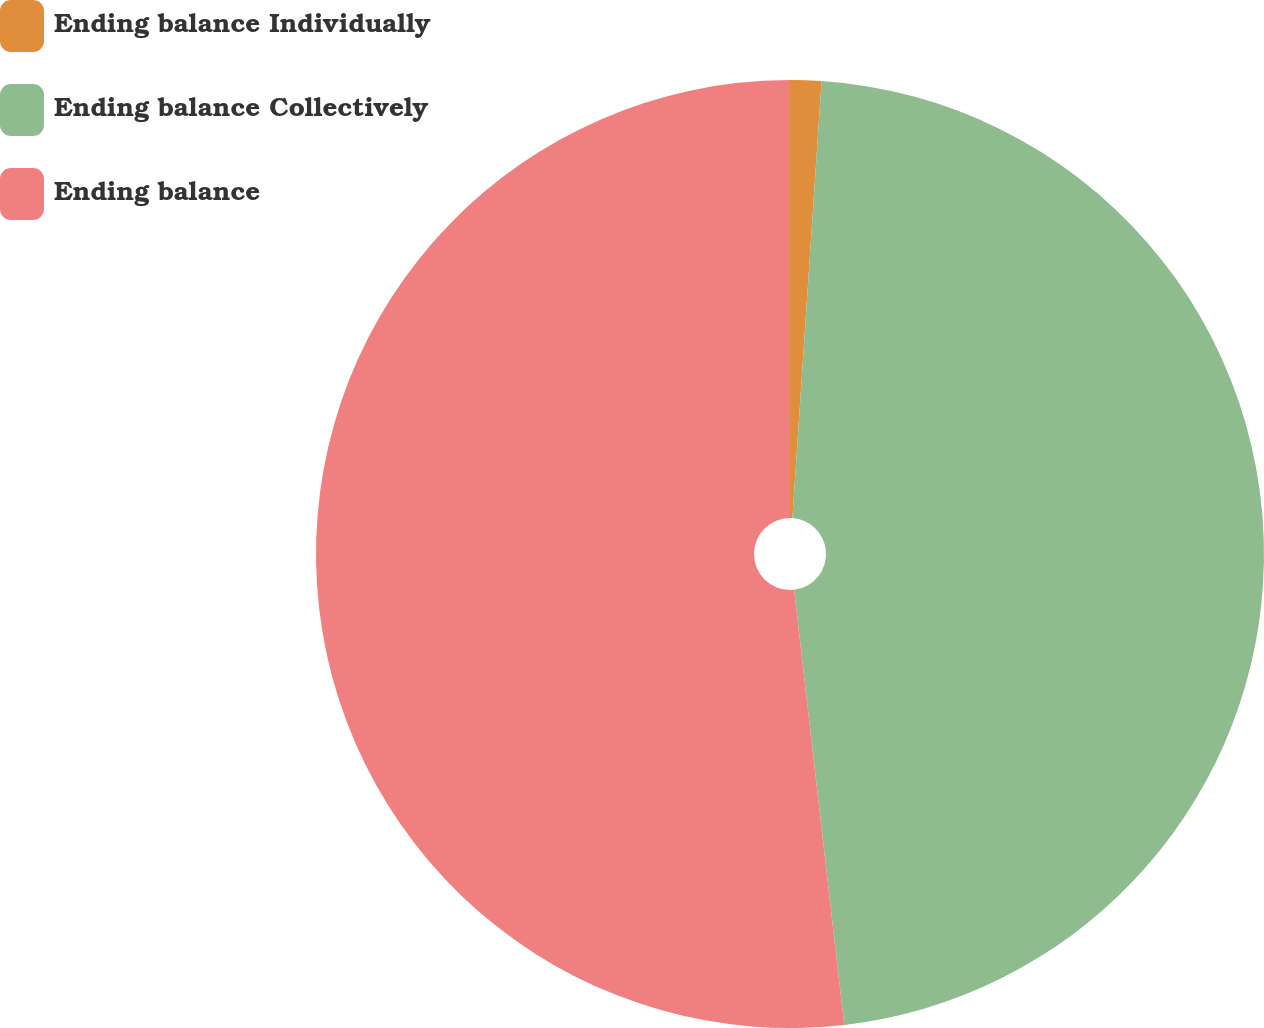Convert chart. <chart><loc_0><loc_0><loc_500><loc_500><pie_chart><fcel>Ending balance Individually<fcel>Ending balance Collectively<fcel>Ending balance<nl><fcel>1.06%<fcel>47.11%<fcel>51.82%<nl></chart> 